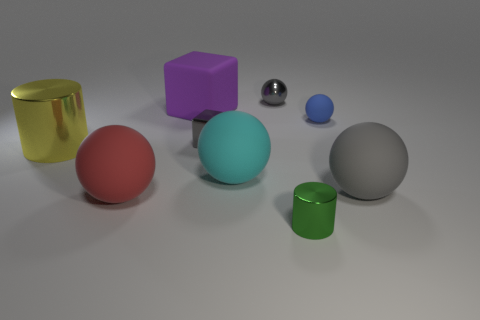Can you tell me the colors of all the objects in the image? Certainly! In the image, there is a red sphere, a teal sphere, a grey sphere, a small blue sphere, a violet cube, a metallic silver cube, and two cylinders, one gold and one green.  Are there shadows cast by every object, and if so, what does that tell us about the light source? Yes, each object in the image has a shadow, indicating that there is a light source present in the scene. The shadows are relatively soft and spread out, suggesting the light source is not extremely close to the objects. The direction of the shadows also indicates that the light source is coming from the upper left side of the frame. 